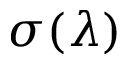Convert formula to latex. <formula><loc_0><loc_0><loc_500><loc_500>\sigma ( \lambda )</formula> 